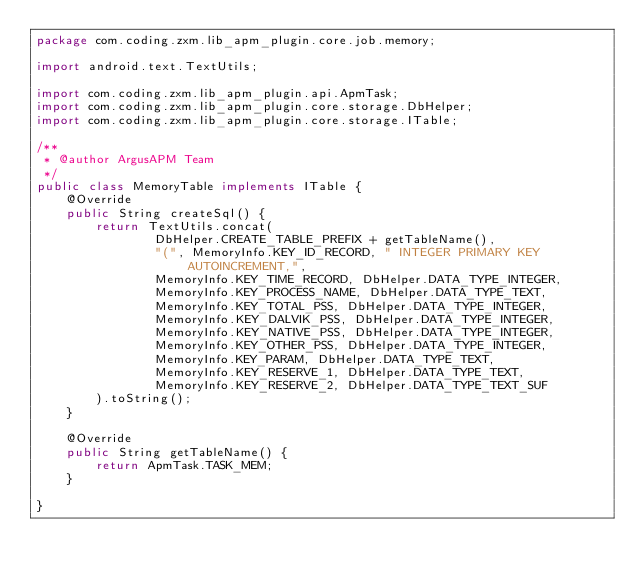<code> <loc_0><loc_0><loc_500><loc_500><_Java_>package com.coding.zxm.lib_apm_plugin.core.job.memory;

import android.text.TextUtils;

import com.coding.zxm.lib_apm_plugin.api.ApmTask;
import com.coding.zxm.lib_apm_plugin.core.storage.DbHelper;
import com.coding.zxm.lib_apm_plugin.core.storage.ITable;

/**
 * @author ArgusAPM Team
 */
public class MemoryTable implements ITable {
    @Override
    public String createSql() {
        return TextUtils.concat(
                DbHelper.CREATE_TABLE_PREFIX + getTableName(),
                "(", MemoryInfo.KEY_ID_RECORD, " INTEGER PRIMARY KEY AUTOINCREMENT,",
                MemoryInfo.KEY_TIME_RECORD, DbHelper.DATA_TYPE_INTEGER,
                MemoryInfo.KEY_PROCESS_NAME, DbHelper.DATA_TYPE_TEXT,
                MemoryInfo.KEY_TOTAL_PSS, DbHelper.DATA_TYPE_INTEGER,
                MemoryInfo.KEY_DALVIK_PSS, DbHelper.DATA_TYPE_INTEGER,
                MemoryInfo.KEY_NATIVE_PSS, DbHelper.DATA_TYPE_INTEGER,
                MemoryInfo.KEY_OTHER_PSS, DbHelper.DATA_TYPE_INTEGER,
                MemoryInfo.KEY_PARAM, DbHelper.DATA_TYPE_TEXT,
                MemoryInfo.KEY_RESERVE_1, DbHelper.DATA_TYPE_TEXT,
                MemoryInfo.KEY_RESERVE_2, DbHelper.DATA_TYPE_TEXT_SUF
        ).toString();
    }

    @Override
    public String getTableName() {
        return ApmTask.TASK_MEM;
    }

}</code> 